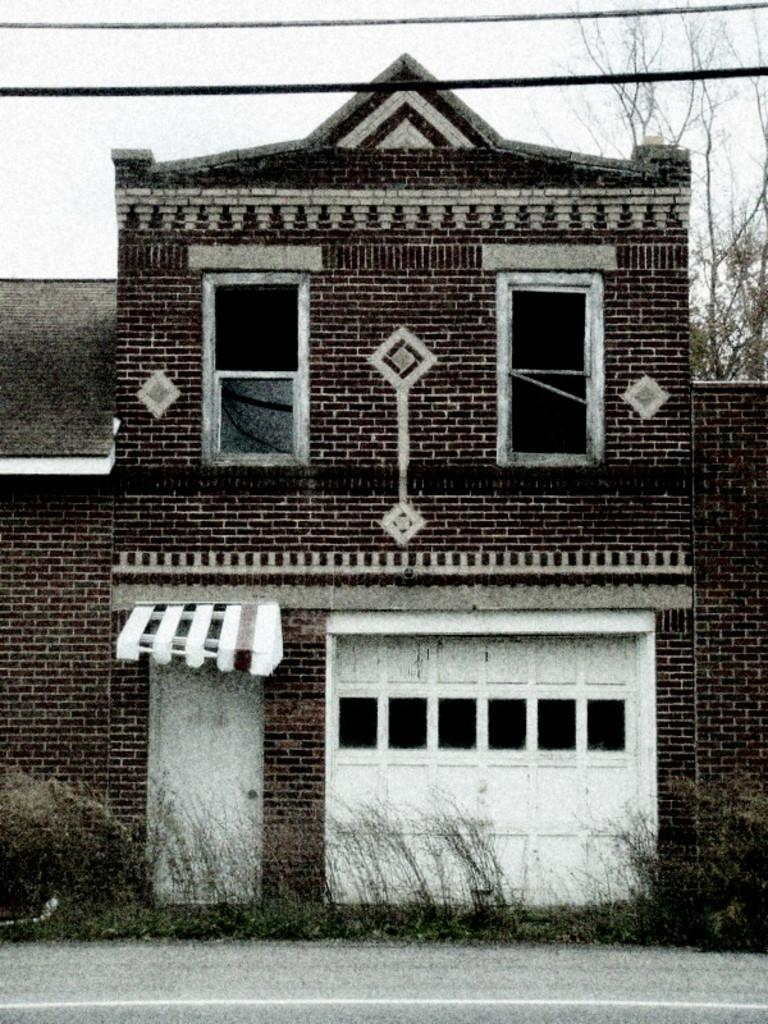What type of structure is in the image? There is a building in the image. What feature of the building is mentioned in the facts? The building has doors. What type of vegetation is present in the image? Grass is present in the image. What else can be seen in the image besides the building and grass? Wires and trees are visible in the image. What can be seen in the background of the image? The sky is visible in the background of the image. How many ladybugs are sitting on the passenger's shoulder in the image? There are no ladybugs or passengers present in the image. What type of power is being generated by the building in the image? The facts provided do not mention any power generation related to the building. 